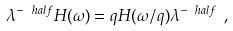Convert formula to latex. <formula><loc_0><loc_0><loc_500><loc_500>\lambda ^ { - \ h a l f } H ( \omega ) = q H ( \omega / q ) \lambda ^ { - \ h a l f } \ ,</formula> 